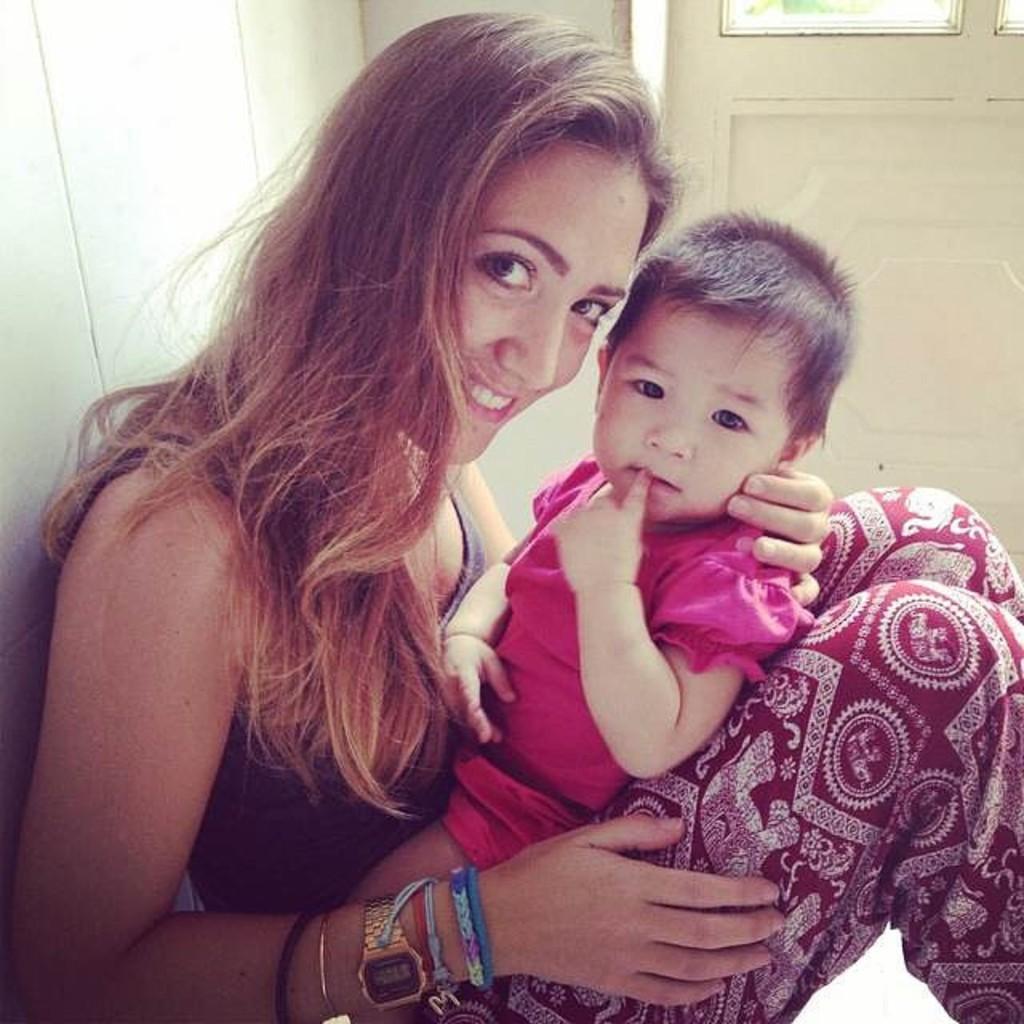In one or two sentences, can you explain what this image depicts? In this image, we can see two people. We can also see the wall and a window. 